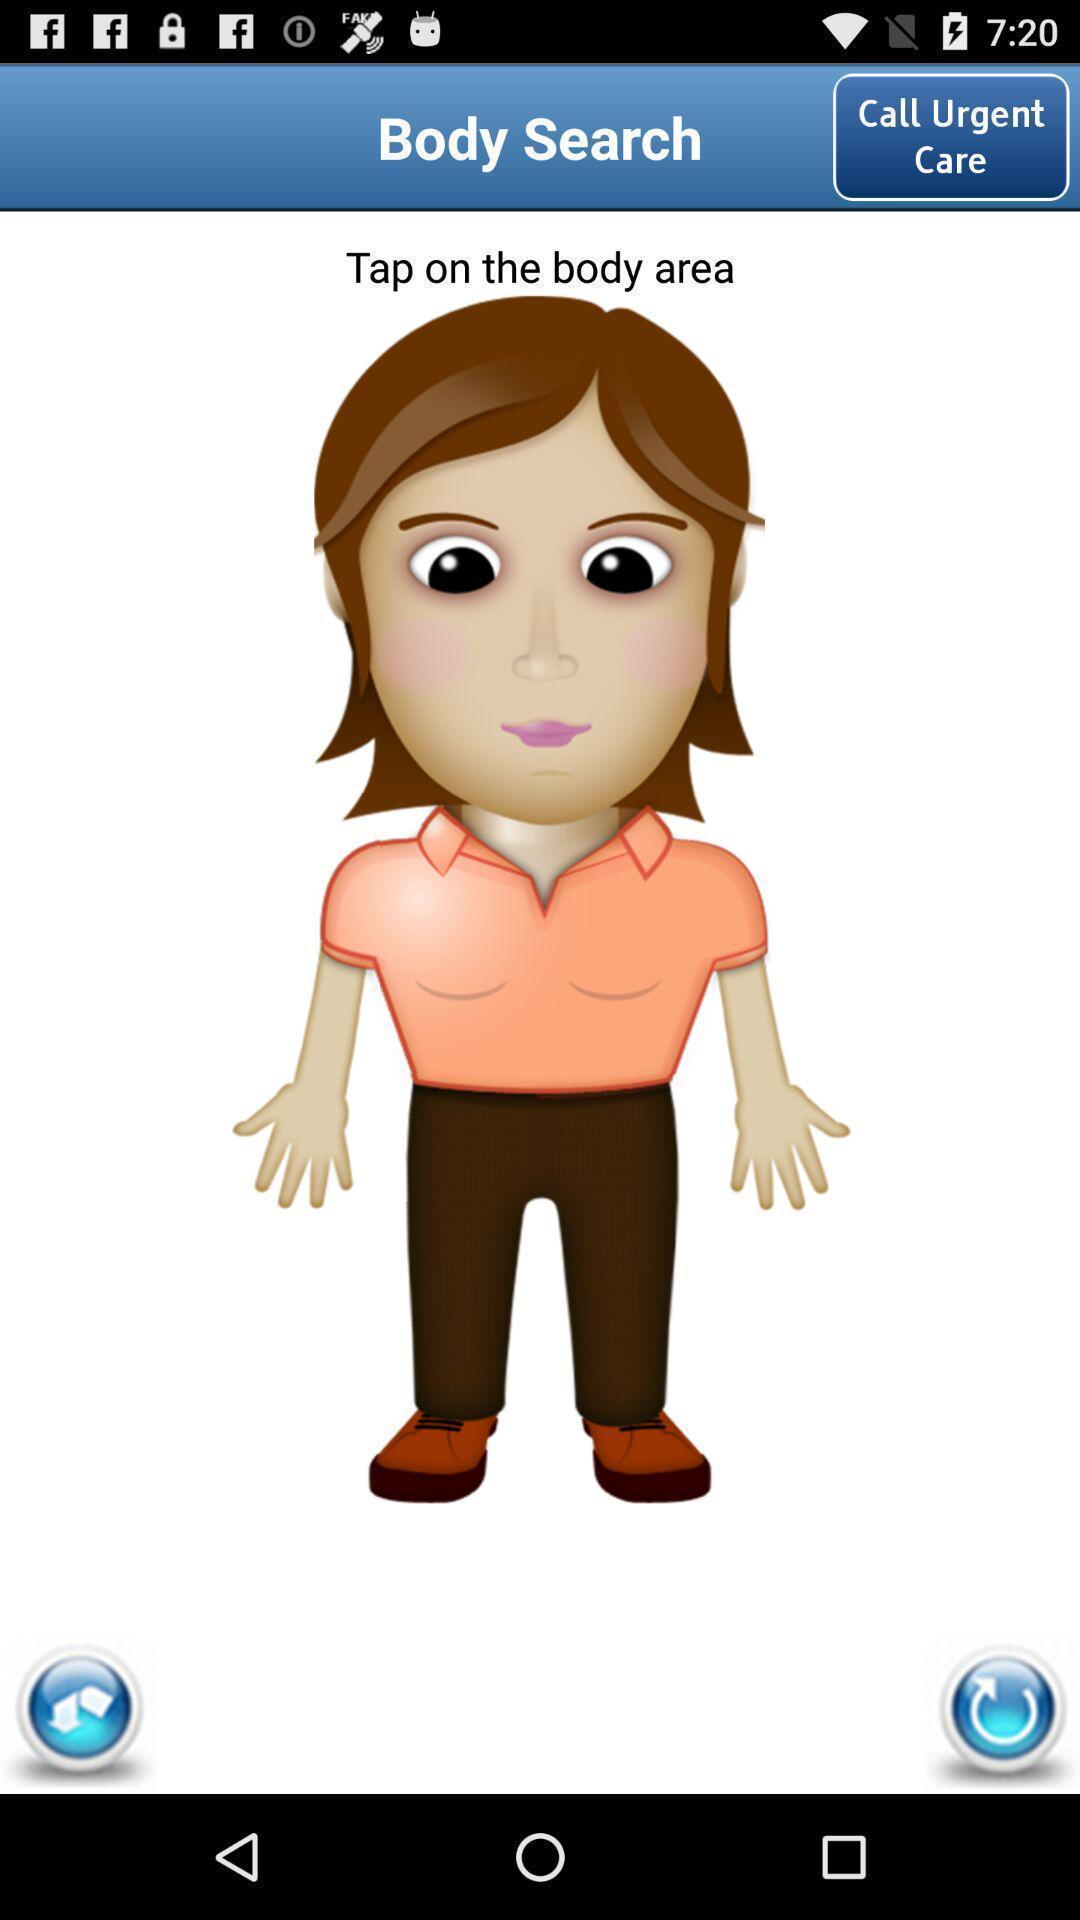Please provide a description for this image. Page displaying with a animated image with few options. 